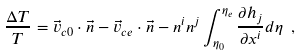Convert formula to latex. <formula><loc_0><loc_0><loc_500><loc_500>\frac { \Delta T } { T } = \vec { v } _ { c 0 } \cdot \vec { n } - \vec { v } _ { c e } \cdot \vec { n } - n ^ { i } n ^ { j } \int ^ { \eta _ { e } } _ { \eta _ { 0 } } \frac { \partial h _ { j } } { \partial x ^ { i } } d \eta \ ,</formula> 